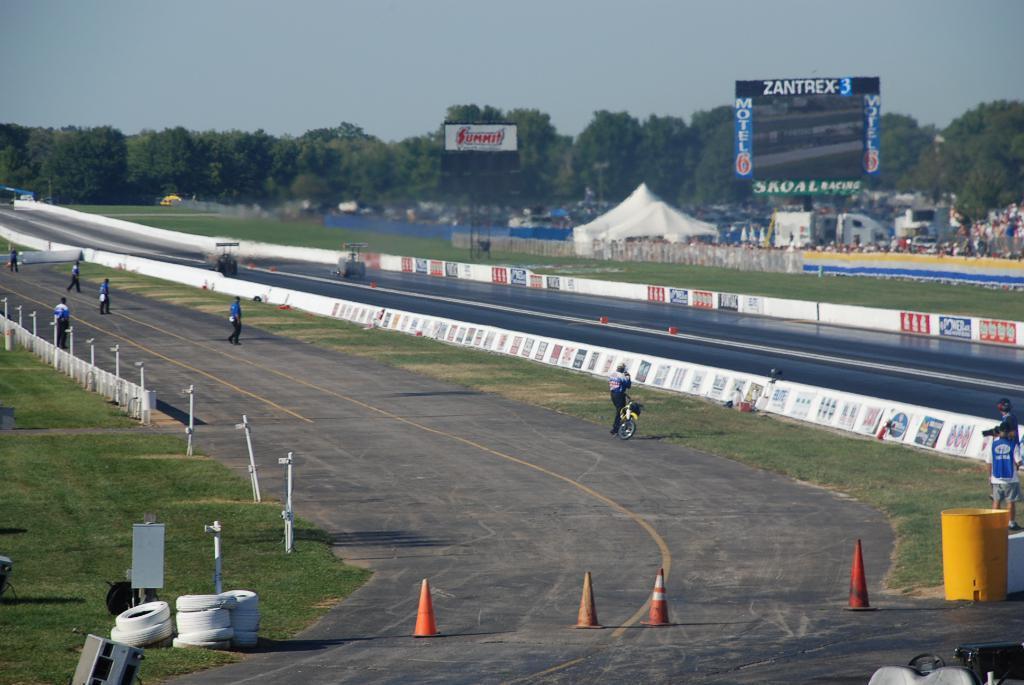Describe this image in one or two sentences. In this picture we can see grass at the left bottom, there are some people walking in the middle, in the background we can see tree, a screen, tents and fencing, on the right side there are two persons standing, we can see traffic cones and tyres at the bottom, a person in the middle is holding a bicycle, we can see two vehicles in the middle, there is a hoarding and the sky at the top of the picture, at the right bottom there is a barrel. 